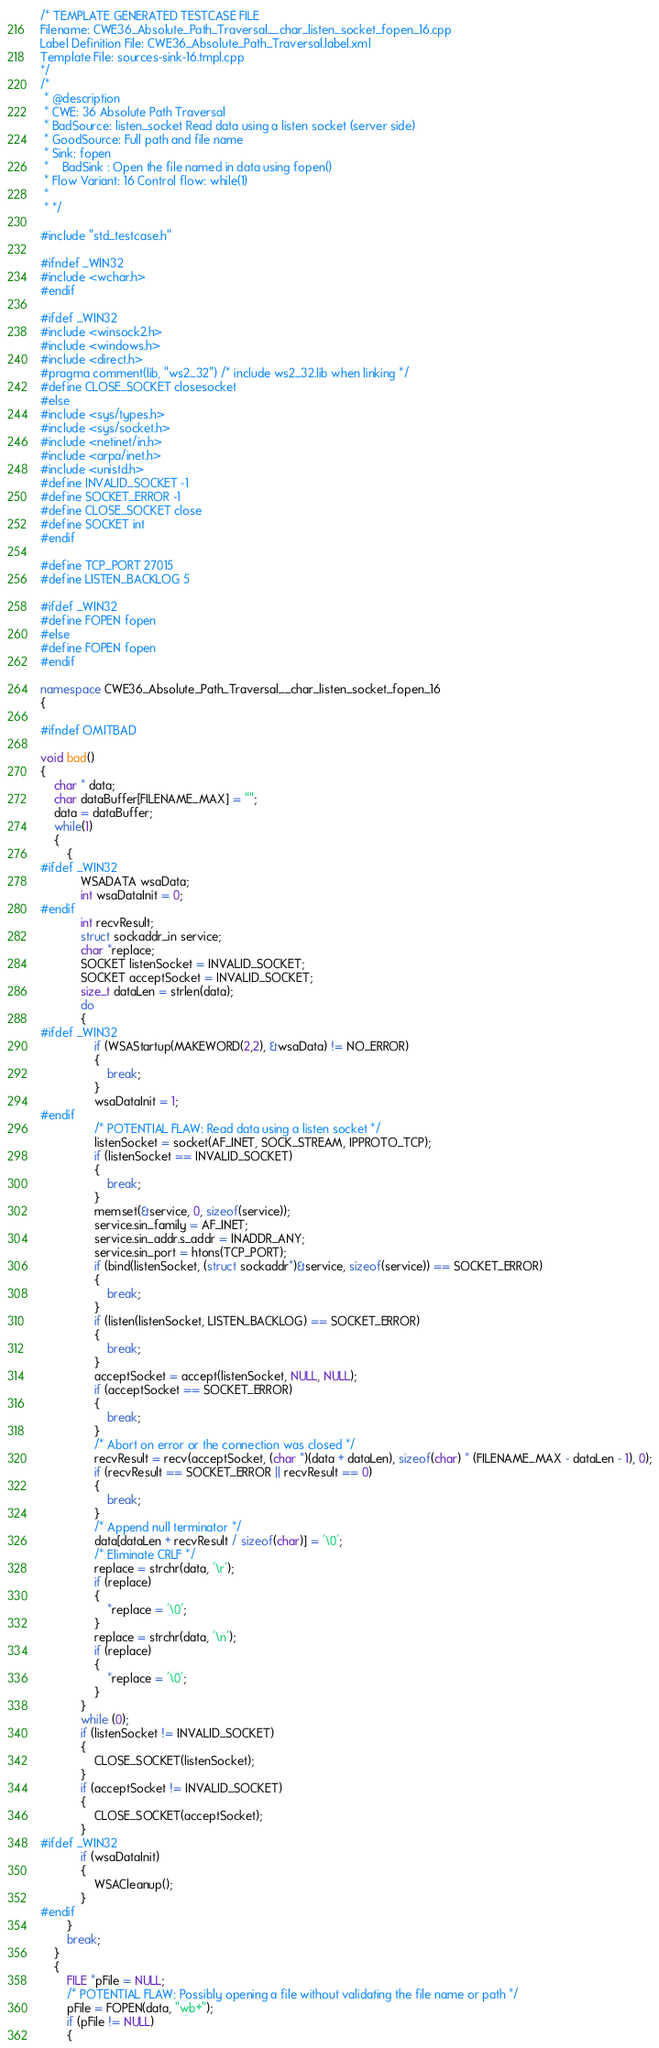Convert code to text. <code><loc_0><loc_0><loc_500><loc_500><_C++_>/* TEMPLATE GENERATED TESTCASE FILE
Filename: CWE36_Absolute_Path_Traversal__char_listen_socket_fopen_16.cpp
Label Definition File: CWE36_Absolute_Path_Traversal.label.xml
Template File: sources-sink-16.tmpl.cpp
*/
/*
 * @description
 * CWE: 36 Absolute Path Traversal
 * BadSource: listen_socket Read data using a listen socket (server side)
 * GoodSource: Full path and file name
 * Sink: fopen
 *    BadSink : Open the file named in data using fopen()
 * Flow Variant: 16 Control flow: while(1)
 *
 * */

#include "std_testcase.h"

#ifndef _WIN32
#include <wchar.h>
#endif

#ifdef _WIN32
#include <winsock2.h>
#include <windows.h>
#include <direct.h>
#pragma comment(lib, "ws2_32") /* include ws2_32.lib when linking */
#define CLOSE_SOCKET closesocket
#else
#include <sys/types.h>
#include <sys/socket.h>
#include <netinet/in.h>
#include <arpa/inet.h>
#include <unistd.h>
#define INVALID_SOCKET -1
#define SOCKET_ERROR -1
#define CLOSE_SOCKET close
#define SOCKET int
#endif

#define TCP_PORT 27015
#define LISTEN_BACKLOG 5

#ifdef _WIN32
#define FOPEN fopen
#else
#define FOPEN fopen
#endif

namespace CWE36_Absolute_Path_Traversal__char_listen_socket_fopen_16
{

#ifndef OMITBAD

void bad()
{
    char * data;
    char dataBuffer[FILENAME_MAX] = "";
    data = dataBuffer;
    while(1)
    {
        {
#ifdef _WIN32
            WSADATA wsaData;
            int wsaDataInit = 0;
#endif
            int recvResult;
            struct sockaddr_in service;
            char *replace;
            SOCKET listenSocket = INVALID_SOCKET;
            SOCKET acceptSocket = INVALID_SOCKET;
            size_t dataLen = strlen(data);
            do
            {
#ifdef _WIN32
                if (WSAStartup(MAKEWORD(2,2), &wsaData) != NO_ERROR)
                {
                    break;
                }
                wsaDataInit = 1;
#endif
                /* POTENTIAL FLAW: Read data using a listen socket */
                listenSocket = socket(AF_INET, SOCK_STREAM, IPPROTO_TCP);
                if (listenSocket == INVALID_SOCKET)
                {
                    break;
                }
                memset(&service, 0, sizeof(service));
                service.sin_family = AF_INET;
                service.sin_addr.s_addr = INADDR_ANY;
                service.sin_port = htons(TCP_PORT);
                if (bind(listenSocket, (struct sockaddr*)&service, sizeof(service)) == SOCKET_ERROR)
                {
                    break;
                }
                if (listen(listenSocket, LISTEN_BACKLOG) == SOCKET_ERROR)
                {
                    break;
                }
                acceptSocket = accept(listenSocket, NULL, NULL);
                if (acceptSocket == SOCKET_ERROR)
                {
                    break;
                }
                /* Abort on error or the connection was closed */
                recvResult = recv(acceptSocket, (char *)(data + dataLen), sizeof(char) * (FILENAME_MAX - dataLen - 1), 0);
                if (recvResult == SOCKET_ERROR || recvResult == 0)
                {
                    break;
                }
                /* Append null terminator */
                data[dataLen + recvResult / sizeof(char)] = '\0';
                /* Eliminate CRLF */
                replace = strchr(data, '\r');
                if (replace)
                {
                    *replace = '\0';
                }
                replace = strchr(data, '\n');
                if (replace)
                {
                    *replace = '\0';
                }
            }
            while (0);
            if (listenSocket != INVALID_SOCKET)
            {
                CLOSE_SOCKET(listenSocket);
            }
            if (acceptSocket != INVALID_SOCKET)
            {
                CLOSE_SOCKET(acceptSocket);
            }
#ifdef _WIN32
            if (wsaDataInit)
            {
                WSACleanup();
            }
#endif
        }
        break;
    }
    {
        FILE *pFile = NULL;
        /* POTENTIAL FLAW: Possibly opening a file without validating the file name or path */
        pFile = FOPEN(data, "wb+");
        if (pFile != NULL)
        {</code> 